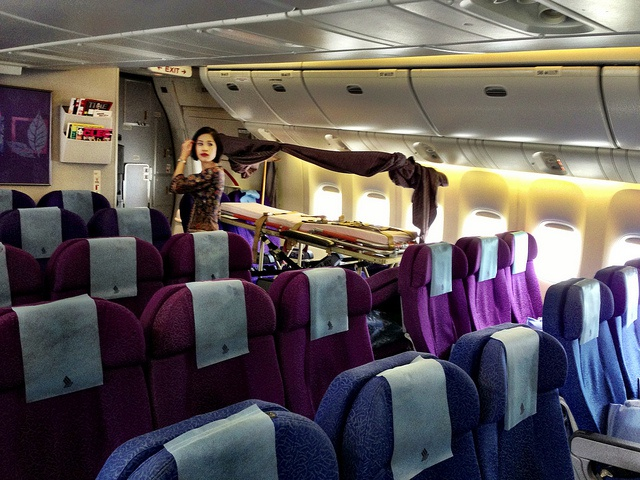Describe the objects in this image and their specific colors. I can see airplane in black, gray, darkgray, tan, and ivory tones, chair in gray, black, purple, and darkblue tones, chair in gray, black, navy, and blue tones, chair in gray, black, navy, and darkgray tones, and chair in gray, black, and purple tones in this image. 